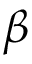<formula> <loc_0><loc_0><loc_500><loc_500>\beta</formula> 